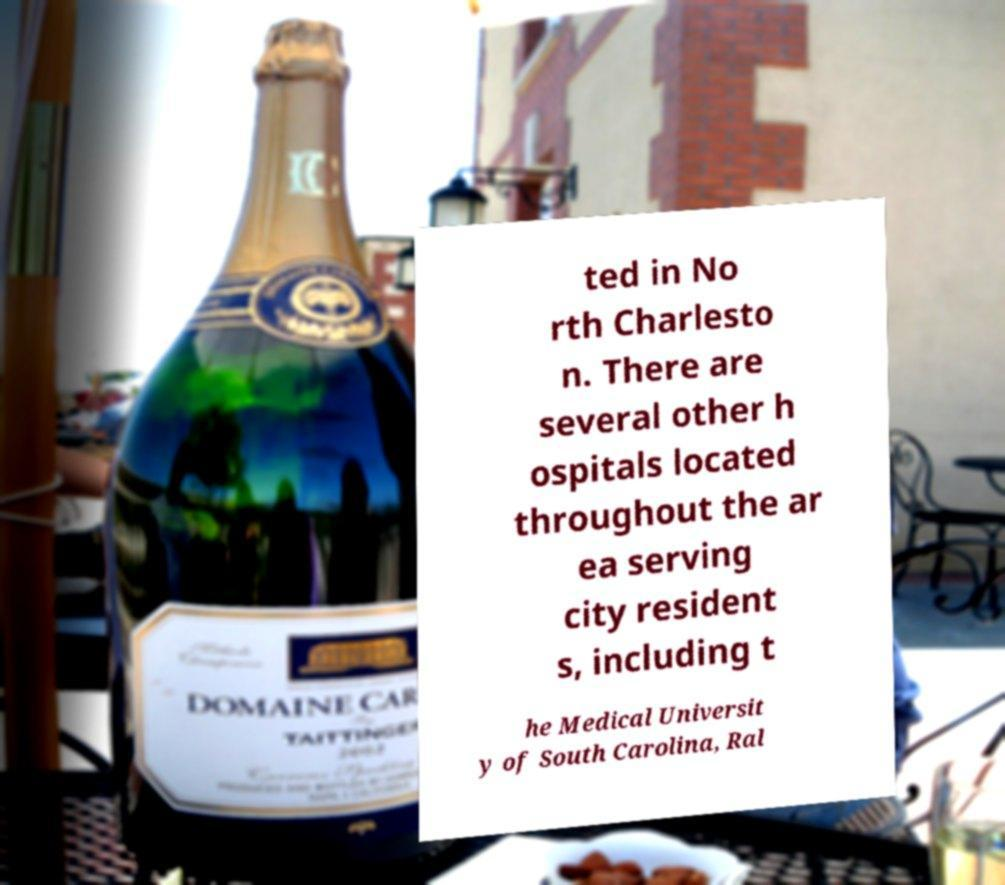What messages or text are displayed in this image? I need them in a readable, typed format. ted in No rth Charlesto n. There are several other h ospitals located throughout the ar ea serving city resident s, including t he Medical Universit y of South Carolina, Ral 